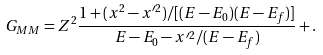Convert formula to latex. <formula><loc_0><loc_0><loc_500><loc_500>G _ { M M } = Z ^ { 2 } \frac { 1 + ( x ^ { 2 } - x ^ { \prime 2 } ) / [ ( E - E _ { 0 } ) ( E - E _ { f } ) ] } { E - E _ { 0 } - x ^ { \prime 2 } / ( E - E _ { f } ) } + .</formula> 